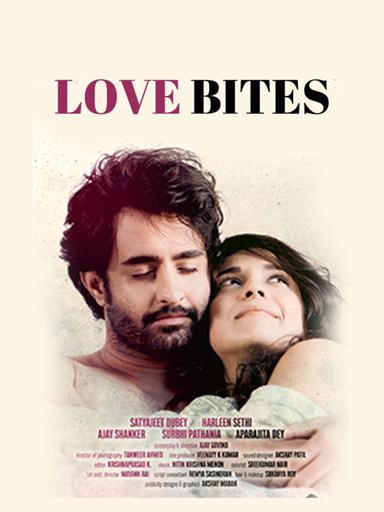Who are the actors mentioned in the "Love Bites" movie poster? The "Love Bites" movie poster features Satyajeet Dubey, Arleen Sethi, Aly Shaner, Surohi Pathania, and Aprajita Dey. Each of these actors brings their unique talent to this romantic drama, set against a visually appealing background that hints at the complexity and sweetness of love's adventures. 